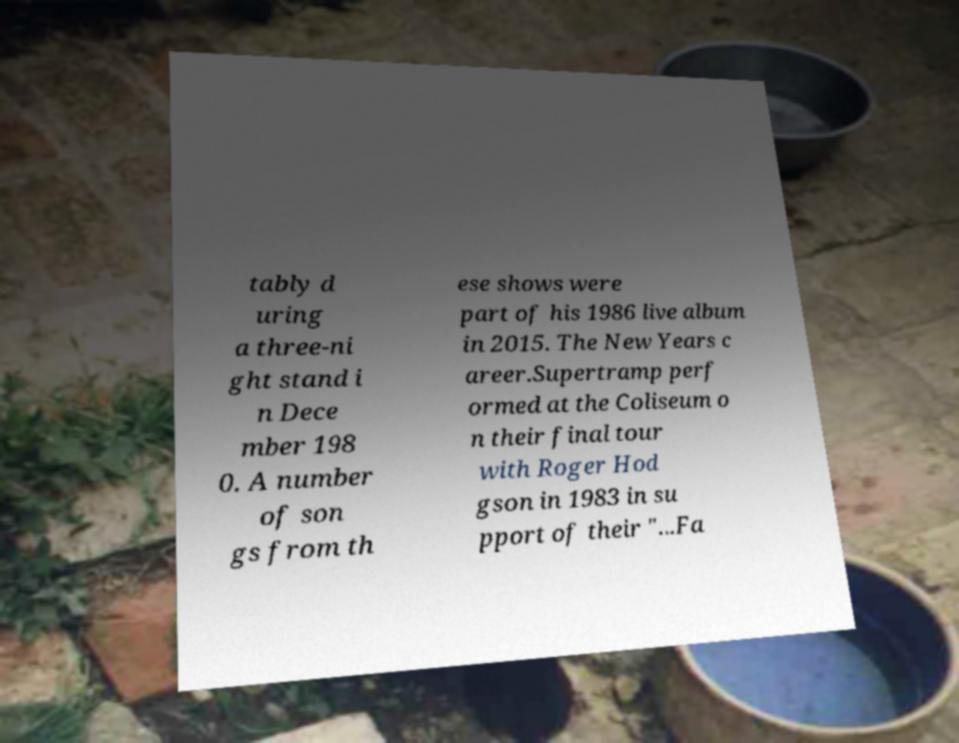Could you extract and type out the text from this image? tably d uring a three-ni ght stand i n Dece mber 198 0. A number of son gs from th ese shows were part of his 1986 live album in 2015. The New Years c areer.Supertramp perf ormed at the Coliseum o n their final tour with Roger Hod gson in 1983 in su pport of their "...Fa 